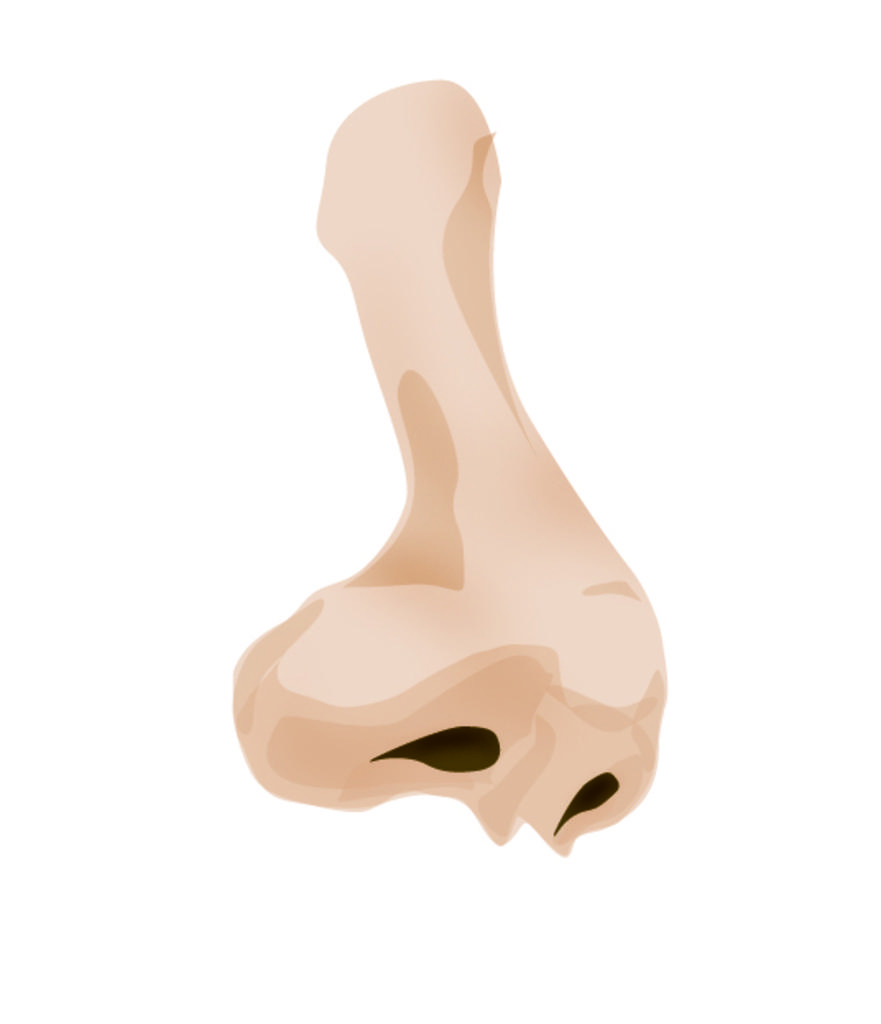What is the main subject of the image? The main subject of the image is an animated sketch of a person's nose. What type of drawing is depicted in the image? The image contains an animated sketch of a person's nose. What color is the jelly in the image? There is no jelly present in the image; it features an animated sketch of a person's nose. Can you describe the kitty playing with the cellar in the image? There is no kitty or cellar present in the image; it only contains an animated sketch of a person's nose. 